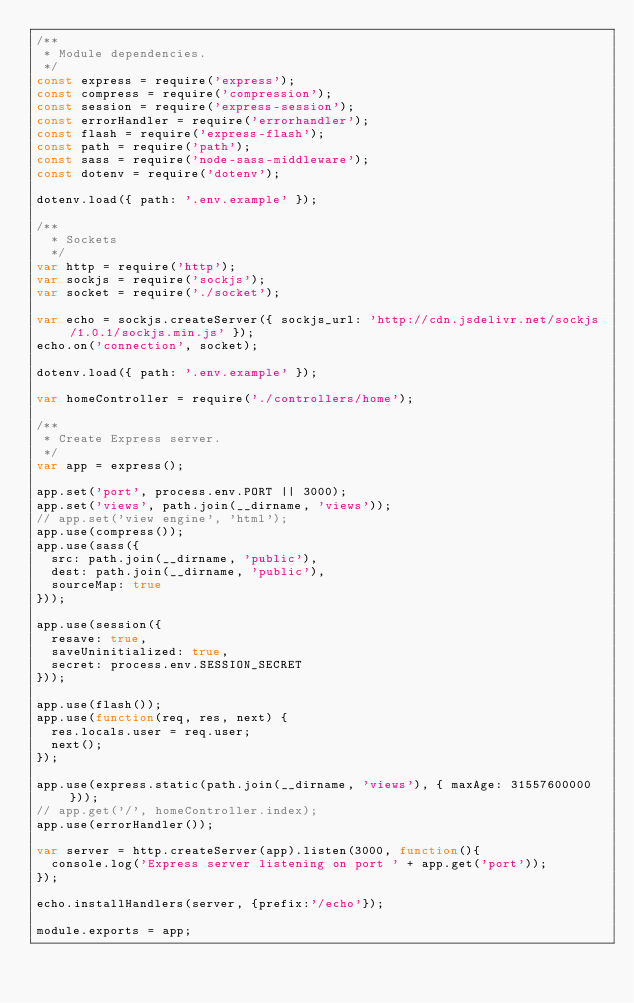Convert code to text. <code><loc_0><loc_0><loc_500><loc_500><_JavaScript_>/**
 * Module dependencies.
 */
const express = require('express');
const compress = require('compression');
const session = require('express-session');
const errorHandler = require('errorhandler');
const flash = require('express-flash');
const path = require('path');
const sass = require('node-sass-middleware');
const dotenv = require('dotenv');

dotenv.load({ path: '.env.example' });

/**
  * Sockets
  */
var http = require('http');
var sockjs = require('sockjs');
var socket = require('./socket');

var echo = sockjs.createServer({ sockjs_url: 'http://cdn.jsdelivr.net/sockjs/1.0.1/sockjs.min.js' });
echo.on('connection', socket);

dotenv.load({ path: '.env.example' });

var homeController = require('./controllers/home');

/**
 * Create Express server.
 */
var app = express();

app.set('port', process.env.PORT || 3000);
app.set('views', path.join(__dirname, 'views'));
// app.set('view engine', 'html');
app.use(compress());
app.use(sass({
  src: path.join(__dirname, 'public'),
  dest: path.join(__dirname, 'public'),
  sourceMap: true
}));

app.use(session({
  resave: true,
  saveUninitialized: true,
  secret: process.env.SESSION_SECRET
}));

app.use(flash());
app.use(function(req, res, next) {
  res.locals.user = req.user;
  next();
});

app.use(express.static(path.join(__dirname, 'views'), { maxAge: 31557600000 }));
// app.get('/', homeController.index);
app.use(errorHandler());

var server = http.createServer(app).listen(3000, function(){
  console.log('Express server listening on port ' + app.get('port'));
});

echo.installHandlers(server, {prefix:'/echo'});

module.exports = app;
</code> 